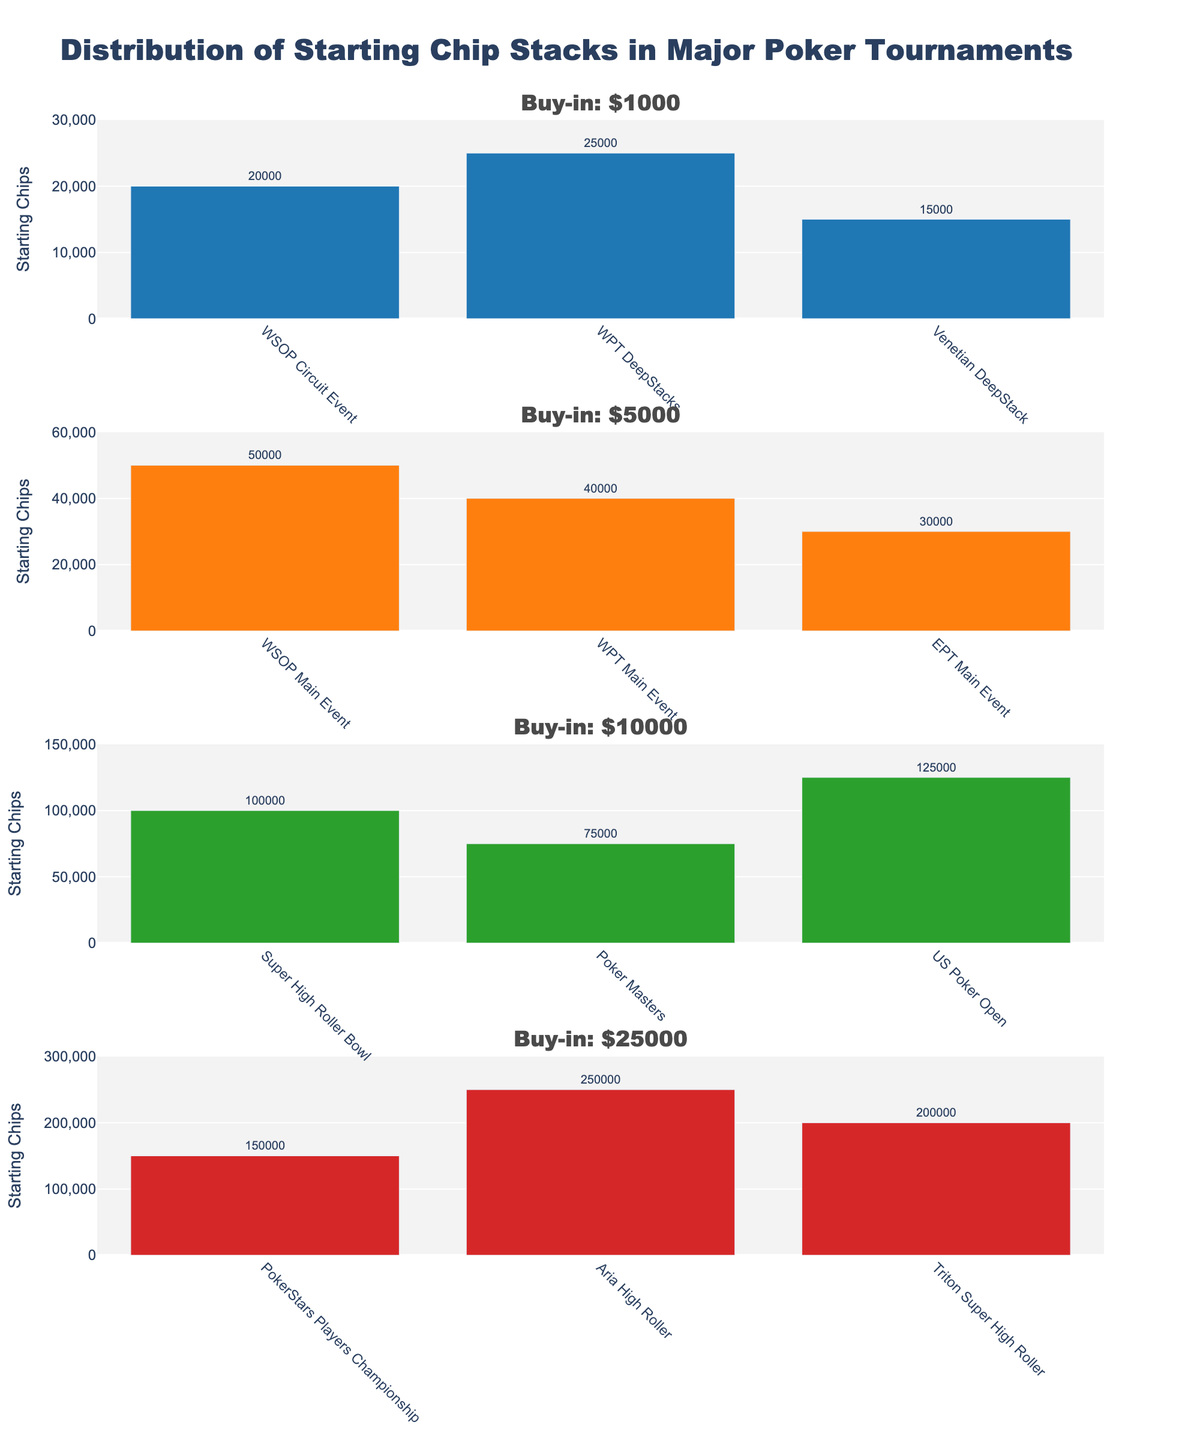What is the highest starting chip stack for the $1000 buy-in tournaments? Look at the subplot for the $1000 buy-in. The highest bar value represents the starting chip stack. Here, WPT DeepStacks has the highest starting chip stack of 25,000.
Answer: 25,000 Which $25000 buy-in tournament has the lowest starting chips? In the $25000 buy-in subplot, compare the heights of the bars. The smallest bar corresponds to the PokerStars Players Championship with 150,000 starting chips.
Answer: PokerStars Players Championship How many tournaments are displayed in the $5000 buy-in subplot? Count the number of bars in the subplot for the $5000 buy-in. There are 3 bars representing the WSOP Main Event, WPT Main Event, and EPT Main Event.
Answer: 3 Compare the starting chips of the WSOP Main Event and the WPT Main Event in the $5000 buy-in. Which one is higher? In the $5000 buy-in subplot, compare the heights of the bars for the WSOP Main Event and WPT Main Event. The WSOP Main Event has 50,000 starting chips, and the WPT Main Event has 40,000. Thus, the WSOP Main Event is higher.
Answer: WSOP Main Event What is the total starting chips for all $10000 buy-in tournaments? Add the starting chips for each tournament in the $10000 buy-in subplot: Super High Roller Bowl (100,000), Poker Masters (75,000), and US Poker Open (125,000). The total is 100,000 + 75,000 + 125,000.
Answer: 300,000 What is the difference in starting chips between the highest and lowest starting chip stacks for the $25000 buy-in tournaments? Find the highest and lowest starting chip stacks in the $25000 buy-in subplot: Aria High Roller (250,000) and PokerStars Players Championship (150,000). The difference is 250,000 - 150,000.
Answer: 100,000 Which tournament represents the highest starting chip stack across all buy-in amounts? Compare the highest bars from each subplot. The tournament with the highest bar in any subplot is the Aria High Roller from the $25000 buy-in, with 250,000 starting chips.
Answer: Aria High Roller Between the $10000 buy-in tournaments, which tournament provides more starting chips than the Poker Masters? Compare the starting chips in the $10000 buy-in tournaments. The US Poker Open (125,000) has more starting chips than the Poker Masters (75,000), whereas the Super High Roller Bowl (100,000) does not.
Answer: US Poker Open 